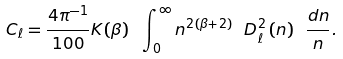Convert formula to latex. <formula><loc_0><loc_0><loc_500><loc_500>C _ { \ell } = \frac { 4 \pi ^ { - 1 } } { 1 0 0 } K ( \beta ) \ \int _ { 0 } ^ { \infty } n ^ { 2 ( \beta + 2 ) } \ D ^ { 2 } _ { \ell } \, ( n ) \ \frac { { d } n } { n } .</formula> 